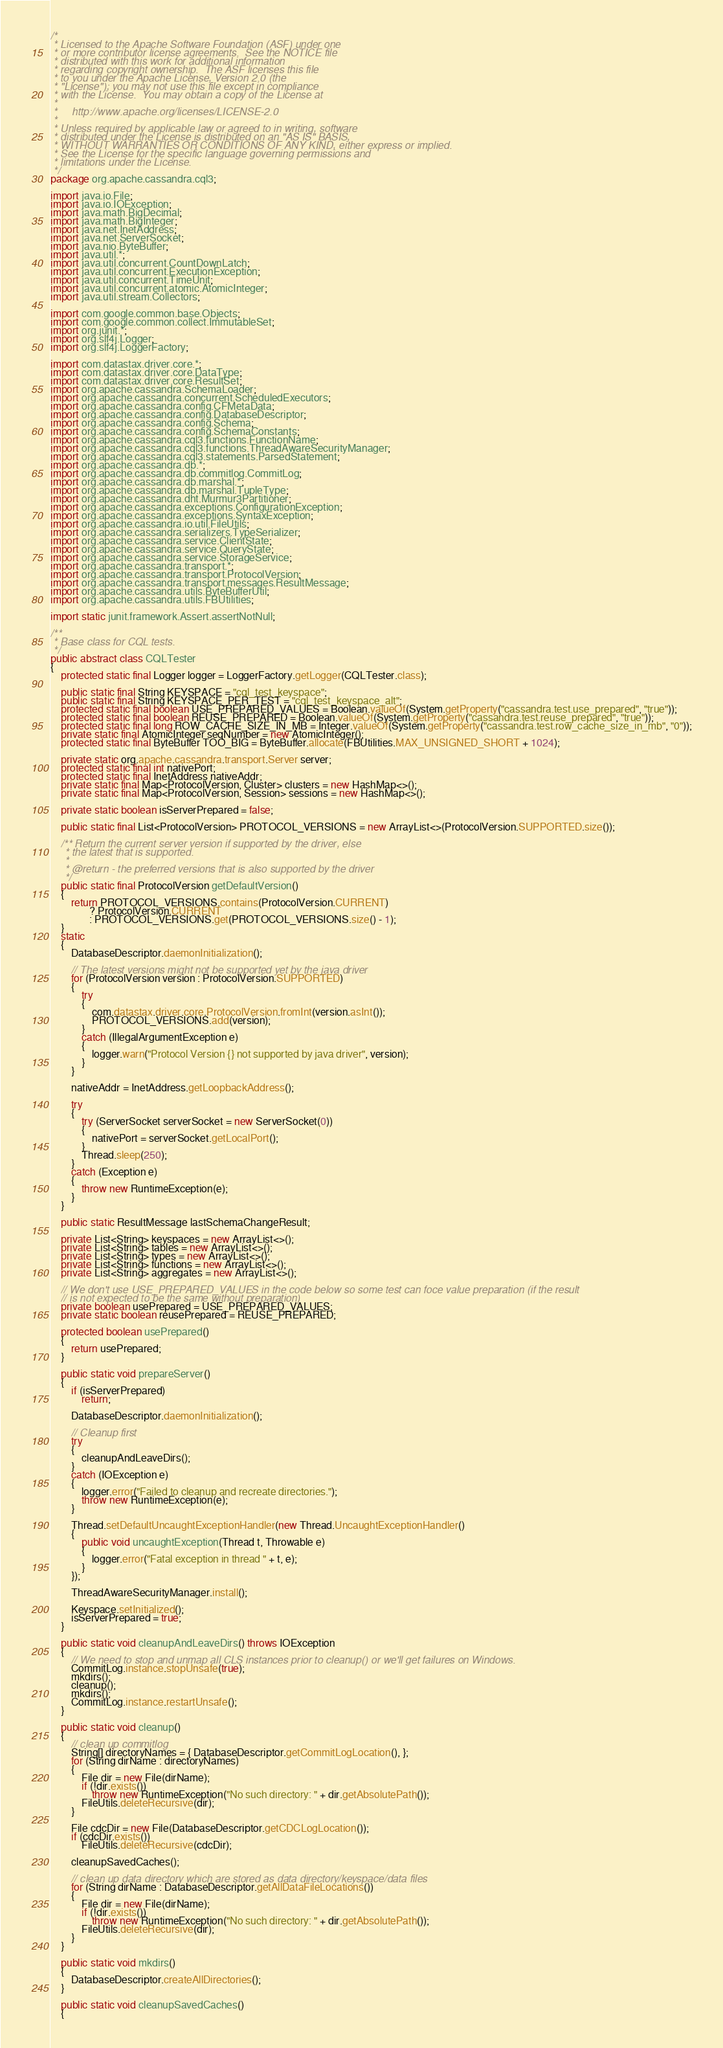<code> <loc_0><loc_0><loc_500><loc_500><_Java_>/*
 * Licensed to the Apache Software Foundation (ASF) under one
 * or more contributor license agreements.  See the NOTICE file
 * distributed with this work for additional information
 * regarding copyright ownership.  The ASF licenses this file
 * to you under the Apache License, Version 2.0 (the
 * "License"); you may not use this file except in compliance
 * with the License.  You may obtain a copy of the License at
 *
 *     http://www.apache.org/licenses/LICENSE-2.0
 *
 * Unless required by applicable law or agreed to in writing, software
 * distributed under the License is distributed on an "AS IS" BASIS,
 * WITHOUT WARRANTIES OR CONDITIONS OF ANY KIND, either express or implied.
 * See the License for the specific language governing permissions and
 * limitations under the License.
 */
package org.apache.cassandra.cql3;

import java.io.File;
import java.io.IOException;
import java.math.BigDecimal;
import java.math.BigInteger;
import java.net.InetAddress;
import java.net.ServerSocket;
import java.nio.ByteBuffer;
import java.util.*;
import java.util.concurrent.CountDownLatch;
import java.util.concurrent.ExecutionException;
import java.util.concurrent.TimeUnit;
import java.util.concurrent.atomic.AtomicInteger;
import java.util.stream.Collectors;

import com.google.common.base.Objects;
import com.google.common.collect.ImmutableSet;
import org.junit.*;
import org.slf4j.Logger;
import org.slf4j.LoggerFactory;

import com.datastax.driver.core.*;
import com.datastax.driver.core.DataType;
import com.datastax.driver.core.ResultSet;
import org.apache.cassandra.SchemaLoader;
import org.apache.cassandra.concurrent.ScheduledExecutors;
import org.apache.cassandra.config.CFMetaData;
import org.apache.cassandra.config.DatabaseDescriptor;
import org.apache.cassandra.config.Schema;
import org.apache.cassandra.config.SchemaConstants;
import org.apache.cassandra.cql3.functions.FunctionName;
import org.apache.cassandra.cql3.functions.ThreadAwareSecurityManager;
import org.apache.cassandra.cql3.statements.ParsedStatement;
import org.apache.cassandra.db.*;
import org.apache.cassandra.db.commitlog.CommitLog;
import org.apache.cassandra.db.marshal.*;
import org.apache.cassandra.db.marshal.TupleType;
import org.apache.cassandra.dht.Murmur3Partitioner;
import org.apache.cassandra.exceptions.ConfigurationException;
import org.apache.cassandra.exceptions.SyntaxException;
import org.apache.cassandra.io.util.FileUtils;
import org.apache.cassandra.serializers.TypeSerializer;
import org.apache.cassandra.service.ClientState;
import org.apache.cassandra.service.QueryState;
import org.apache.cassandra.service.StorageService;
import org.apache.cassandra.transport.*;
import org.apache.cassandra.transport.ProtocolVersion;
import org.apache.cassandra.transport.messages.ResultMessage;
import org.apache.cassandra.utils.ByteBufferUtil;
import org.apache.cassandra.utils.FBUtilities;

import static junit.framework.Assert.assertNotNull;

/**
 * Base class for CQL tests.
 */
public abstract class CQLTester
{
    protected static final Logger logger = LoggerFactory.getLogger(CQLTester.class);

    public static final String KEYSPACE = "cql_test_keyspace";
    public static final String KEYSPACE_PER_TEST = "cql_test_keyspace_alt";
    protected static final boolean USE_PREPARED_VALUES = Boolean.valueOf(System.getProperty("cassandra.test.use_prepared", "true"));
    protected static final boolean REUSE_PREPARED = Boolean.valueOf(System.getProperty("cassandra.test.reuse_prepared", "true"));
    protected static final long ROW_CACHE_SIZE_IN_MB = Integer.valueOf(System.getProperty("cassandra.test.row_cache_size_in_mb", "0"));
    private static final AtomicInteger seqNumber = new AtomicInteger();
    protected static final ByteBuffer TOO_BIG = ByteBuffer.allocate(FBUtilities.MAX_UNSIGNED_SHORT + 1024);

    private static org.apache.cassandra.transport.Server server;
    protected static final int nativePort;
    protected static final InetAddress nativeAddr;
    private static final Map<ProtocolVersion, Cluster> clusters = new HashMap<>();
    private static final Map<ProtocolVersion, Session> sessions = new HashMap<>();

    private static boolean isServerPrepared = false;

    public static final List<ProtocolVersion> PROTOCOL_VERSIONS = new ArrayList<>(ProtocolVersion.SUPPORTED.size());

    /** Return the current server version if supported by the driver, else
     * the latest that is supported.
     *
     * @return - the preferred versions that is also supported by the driver
     */
    public static final ProtocolVersion getDefaultVersion()
    {
        return PROTOCOL_VERSIONS.contains(ProtocolVersion.CURRENT)
               ? ProtocolVersion.CURRENT
               : PROTOCOL_VERSIONS.get(PROTOCOL_VERSIONS.size() - 1);
    }
    static
    {
        DatabaseDescriptor.daemonInitialization();

        // The latest versions might not be supported yet by the java driver
        for (ProtocolVersion version : ProtocolVersion.SUPPORTED)
        {
            try
            {
                com.datastax.driver.core.ProtocolVersion.fromInt(version.asInt());
                PROTOCOL_VERSIONS.add(version);
            }
            catch (IllegalArgumentException e)
            {
                logger.warn("Protocol Version {} not supported by java driver", version);
            }
        }

        nativeAddr = InetAddress.getLoopbackAddress();

        try
        {
            try (ServerSocket serverSocket = new ServerSocket(0))
            {
                nativePort = serverSocket.getLocalPort();
            }
            Thread.sleep(250);
        }
        catch (Exception e)
        {
            throw new RuntimeException(e);
        }
    }

    public static ResultMessage lastSchemaChangeResult;

    private List<String> keyspaces = new ArrayList<>();
    private List<String> tables = new ArrayList<>();
    private List<String> types = new ArrayList<>();
    private List<String> functions = new ArrayList<>();
    private List<String> aggregates = new ArrayList<>();

    // We don't use USE_PREPARED_VALUES in the code below so some test can foce value preparation (if the result
    // is not expected to be the same without preparation)
    private boolean usePrepared = USE_PREPARED_VALUES;
    private static boolean reusePrepared = REUSE_PREPARED;

    protected boolean usePrepared()
    {
        return usePrepared;
    }

    public static void prepareServer()
    {
        if (isServerPrepared)
            return;

        DatabaseDescriptor.daemonInitialization();

        // Cleanup first
        try
        {
            cleanupAndLeaveDirs();
        }
        catch (IOException e)
        {
            logger.error("Failed to cleanup and recreate directories.");
            throw new RuntimeException(e);
        }

        Thread.setDefaultUncaughtExceptionHandler(new Thread.UncaughtExceptionHandler()
        {
            public void uncaughtException(Thread t, Throwable e)
            {
                logger.error("Fatal exception in thread " + t, e);
            }
        });

        ThreadAwareSecurityManager.install();

        Keyspace.setInitialized();
        isServerPrepared = true;
    }

    public static void cleanupAndLeaveDirs() throws IOException
    {
        // We need to stop and unmap all CLS instances prior to cleanup() or we'll get failures on Windows.
        CommitLog.instance.stopUnsafe(true);
        mkdirs();
        cleanup();
        mkdirs();
        CommitLog.instance.restartUnsafe();
    }

    public static void cleanup()
    {
        // clean up commitlog
        String[] directoryNames = { DatabaseDescriptor.getCommitLogLocation(), };
        for (String dirName : directoryNames)
        {
            File dir = new File(dirName);
            if (!dir.exists())
                throw new RuntimeException("No such directory: " + dir.getAbsolutePath());
            FileUtils.deleteRecursive(dir);
        }

        File cdcDir = new File(DatabaseDescriptor.getCDCLogLocation());
        if (cdcDir.exists())
            FileUtils.deleteRecursive(cdcDir);

        cleanupSavedCaches();

        // clean up data directory which are stored as data directory/keyspace/data files
        for (String dirName : DatabaseDescriptor.getAllDataFileLocations())
        {
            File dir = new File(dirName);
            if (!dir.exists())
                throw new RuntimeException("No such directory: " + dir.getAbsolutePath());
            FileUtils.deleteRecursive(dir);
        }
    }

    public static void mkdirs()
    {
        DatabaseDescriptor.createAllDirectories();
    }

    public static void cleanupSavedCaches()
    {</code> 